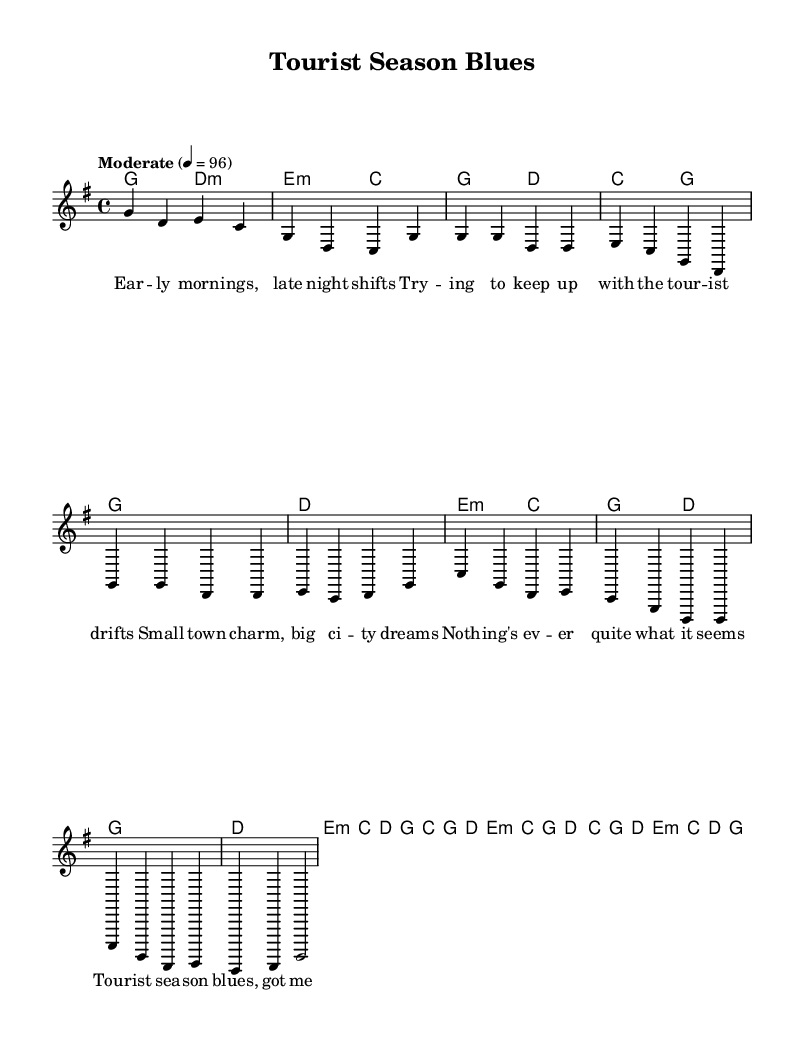What is the key signature of this music? The key signature is G major, which has one sharp (F#). This is indicated by the presence of a sharp sign at the beginning of the staff just after the clef.
Answer: G major What is the time signature of this music? The time signature is 4/4, which is indicated at the beginning of the staff. It tells us there are four beats in each measure and a quarter note receives one beat.
Answer: 4/4 What is the tempo marking for this piece? The tempo marking is indicated as "Moderate" with a metronome marking of 96 beats per minute. This suggests a moderate pace for performing the piece.
Answer: Moderate, 96 How many measures are in the chorus section? By counting the measures from the melody section labeled "Chorus," there are four measures in the chorus. This is determined by looking for the four consecutive measures that form the chorus.
Answer: 4 What is the main theme addressed in the lyrics of this song? The main theme revolves around the challenges faced by someone running a local business in a tourist town, particularly during the busy tourist season. This is inferred from the lyrics expressing struggles and the hustle of maintaining local roots amidst tourism pressures.
Answer: Challenges of local business What type of chords are used predominantly in the verse? The chords in the verse section primarily consist of major and minor chords, specifically G major, D major, E minor, and C major. They provide a mixture of brightness and somberness reflecting the lyrical content.
Answer: Major and minor chords 